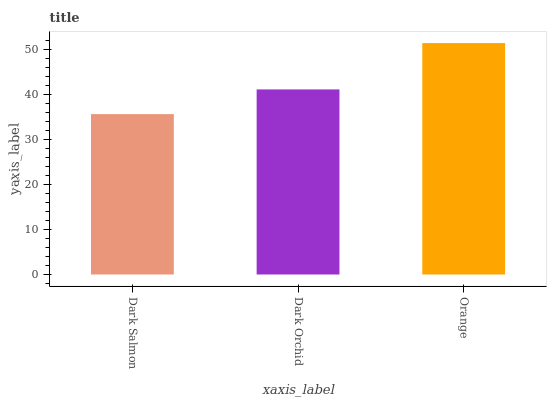Is Dark Salmon the minimum?
Answer yes or no. Yes. Is Orange the maximum?
Answer yes or no. Yes. Is Dark Orchid the minimum?
Answer yes or no. No. Is Dark Orchid the maximum?
Answer yes or no. No. Is Dark Orchid greater than Dark Salmon?
Answer yes or no. Yes. Is Dark Salmon less than Dark Orchid?
Answer yes or no. Yes. Is Dark Salmon greater than Dark Orchid?
Answer yes or no. No. Is Dark Orchid less than Dark Salmon?
Answer yes or no. No. Is Dark Orchid the high median?
Answer yes or no. Yes. Is Dark Orchid the low median?
Answer yes or no. Yes. Is Dark Salmon the high median?
Answer yes or no. No. Is Dark Salmon the low median?
Answer yes or no. No. 